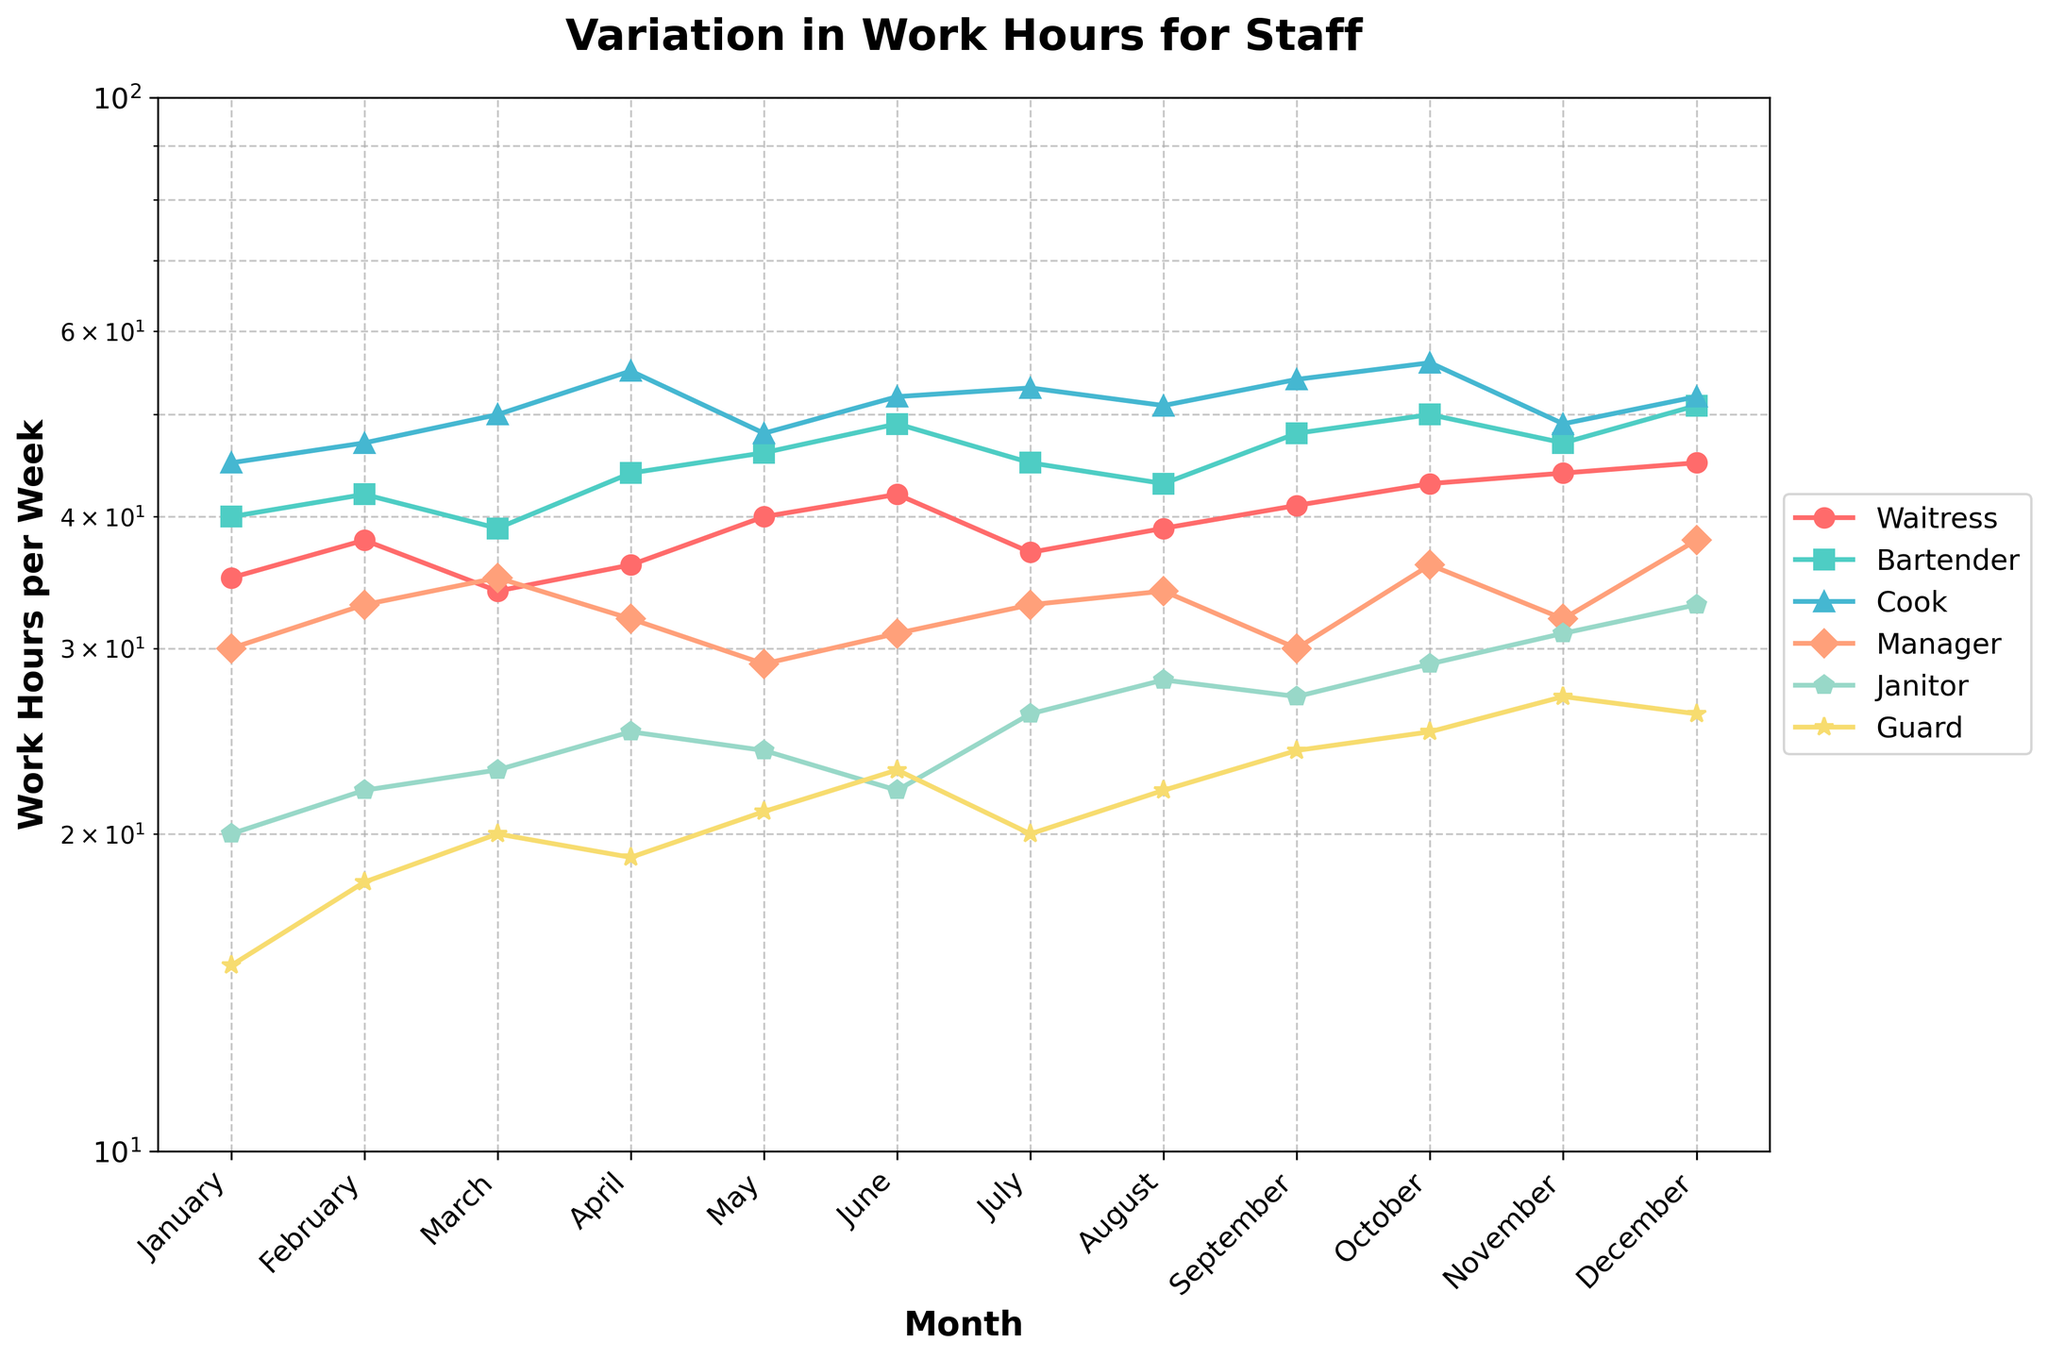What is the title of the figure? The title of the figure is typically located at the top center of the plot. In this case, it reads "Variation in Work Hours for Staff".
Answer: Variation in Work Hours for Staff Which month shows the highest number of work hours for the Waitress role? By observing the Waitress line on the plot, which uses a specific color and marker, we can see that December's point is the highest among all months.
Answer: December What is the minimum work hours per week recorded for the Janitor role, and in which month does this occur? By examining the Janitor line on the log scale plot, the minimum value is observed at 20 hours per week in January.
Answer: January, 20 hours How many roles have their work hours exceeding 50 hours per week in October? To find this, look at October and count the number of lines that cross above the 50-hour mark on the vertical axis. Three roles (Bartender, Cook, and Guard) exceed 50 hours.
Answer: 3 roles Which role shows the most significant increase in work hours from January to December? Calculate the difference in work hours from January to December for each role. The Cook role increases from 45 hours in January to 52 hours in December.
Answer: Cook Compare the work hours in May for the Guard and Manager roles. Which role has more work hours, and by how much? Look at May on the plot, find the points for Guard (21 hours) and Manager (29 hours), and subtract.
Answer: Manager has 8 more hours What is the difference in work hours between the Waitress and Cook for the month of March? Identify March on the plot, then find the Waitress (34 hours) and Cook (50 hours) points, and subtract their values.
Answer: 16 hours What trend is observed in the work hours of the Janitor role throughout the year? By following the Janitor line from January to December, we can see a general increasing trend over the months.
Answer: Increasing trend What is the average work hours per week for the Bartender during the first quarter of the year (January-March)? Sum the Bartender's work hours for January (40), February (42), and March (39) and divide by 3.
Answer: 40.33 hours Which month shows the highest variability (difference) in work hours among all roles? Identify the month with the widest range between the highest and lowest points. December has the highest range (15 hours for Guard, 52 hours for Cook).
Answer: December 